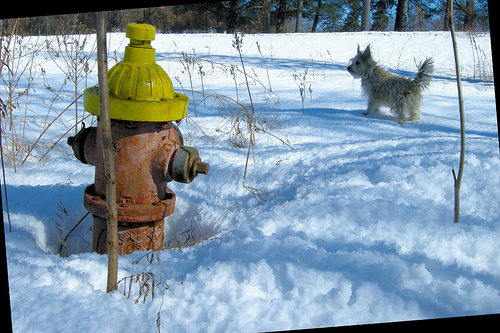<image>What is the dog looking at? It is ambiguous what the dog is looking at, answers include trees, a fire hydrant, a squirrel. What is the dog looking at? I don't know what the dog is looking at. It can be trees, fire hydrant, scenery, weeds, squirrel or something else. 